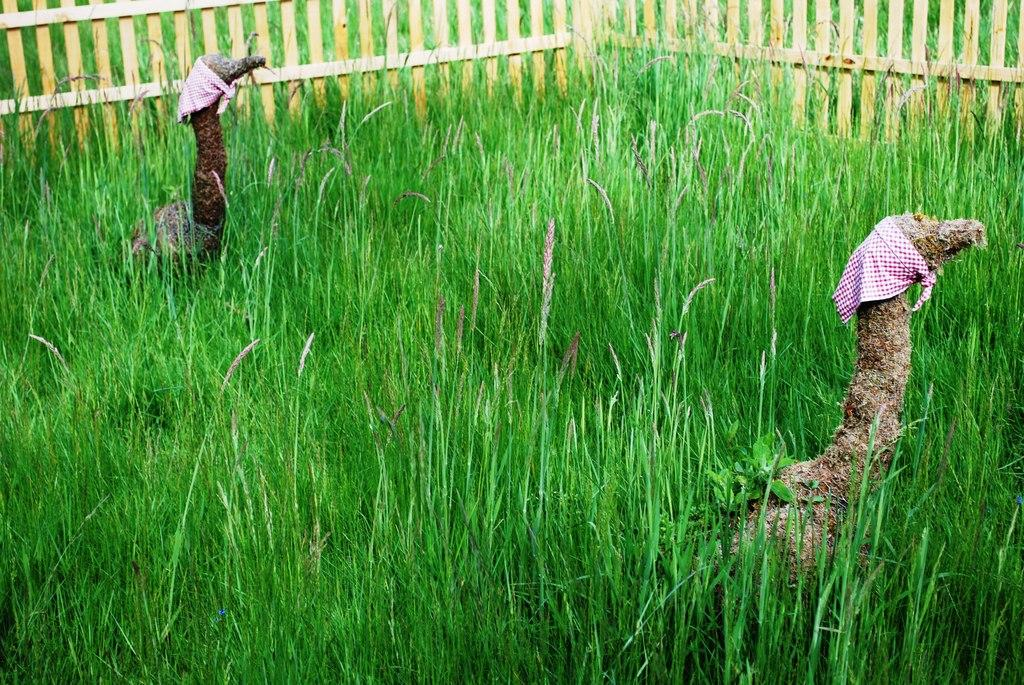What type of vegetation is present in the image? There is grass in the image. What type of fencing can be seen in the image? There is wooden fencing in the image. How many statues of animals are in the image? There are two statues of animals in the image, one in the top left and one in the bottom right. What type of eggnog is being served at the property in the image? There is no mention of eggnog or a property in the image; it features grass, wooden fencing, and statues of animals. What type of instrument is being played by the animal statue in the image? There is no instrument present in the image; the statues are of animals without any additional objects or features. 